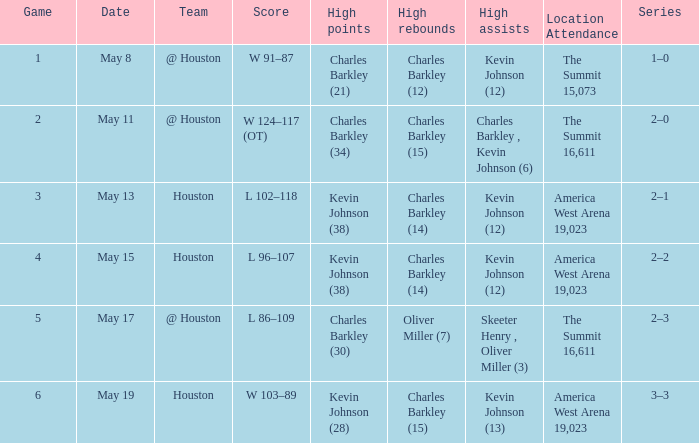In what series did Charles Barkley (34) did most high points? 2–0. 